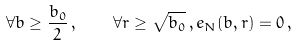<formula> <loc_0><loc_0><loc_500><loc_500>\forall b \geq \frac { b _ { 0 } } 2 \, , \quad \forall r \geq \sqrt { b _ { 0 } } \, , e _ { N } ( b , r ) = 0 \, ,</formula> 